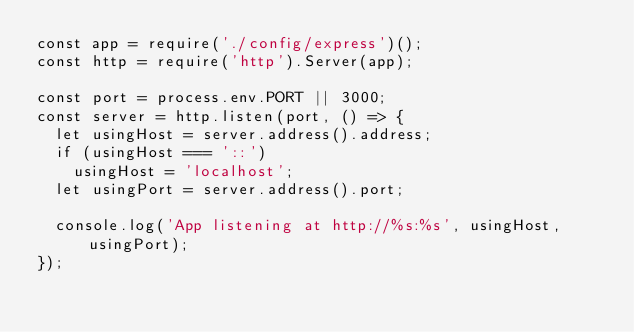Convert code to text. <code><loc_0><loc_0><loc_500><loc_500><_JavaScript_>const app = require('./config/express')();
const http = require('http').Server(app);

const port = process.env.PORT || 3000;
const server = http.listen(port, () => {
  let usingHost = server.address().address;
  if (usingHost === '::')
    usingHost = 'localhost';
  let usingPort = server.address().port;

  console.log('App listening at http://%s:%s', usingHost, usingPort);
});</code> 